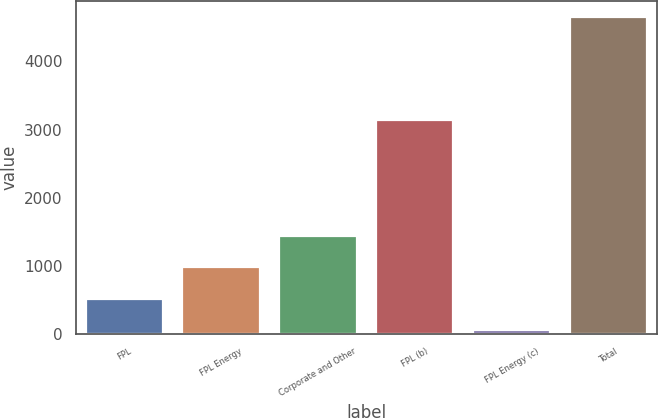Convert chart. <chart><loc_0><loc_0><loc_500><loc_500><bar_chart><fcel>FPL<fcel>FPL Energy<fcel>Corporate and Other<fcel>FPL (b)<fcel>FPL Energy (c)<fcel>Total<nl><fcel>516.7<fcel>976.4<fcel>1436.1<fcel>3145<fcel>57<fcel>4654<nl></chart> 